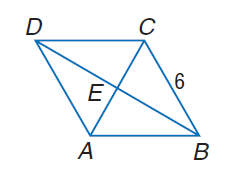Answer the mathemtical geometry problem and directly provide the correct option letter.
Question: In rhombus A B C D, m \angle D A B = 2, m \angle A D C and C B = 6. Find D A.
Choices: A: 3 B: 6 C: 9 D: 12 B 